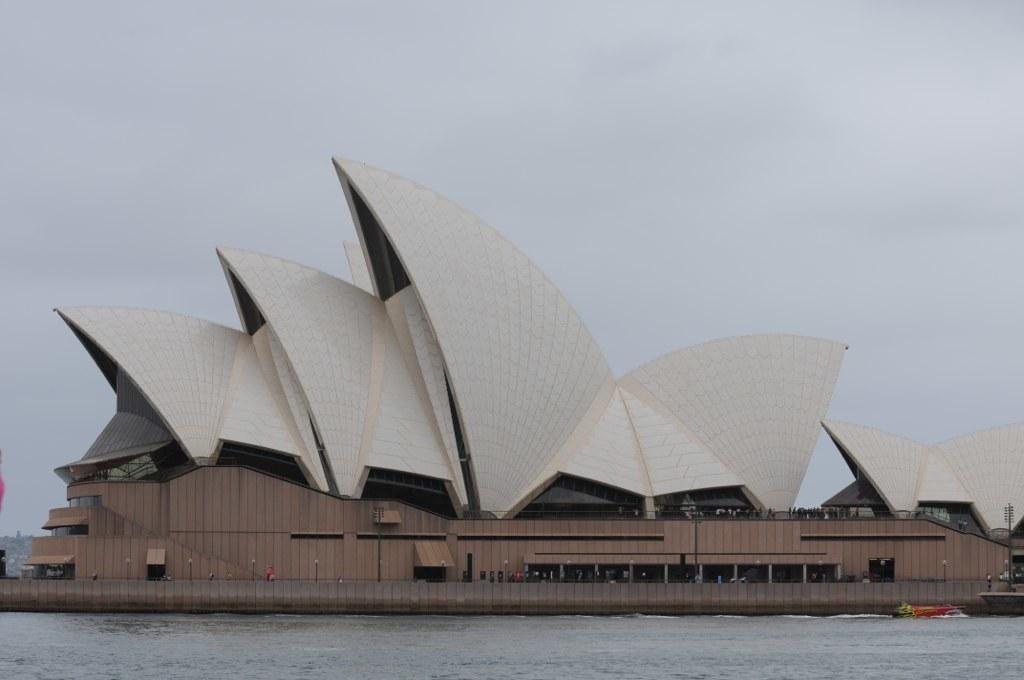Please provide a concise description of this image. In this image there is a building and we can see water. On the right there is a pole. In the background there is sky. 